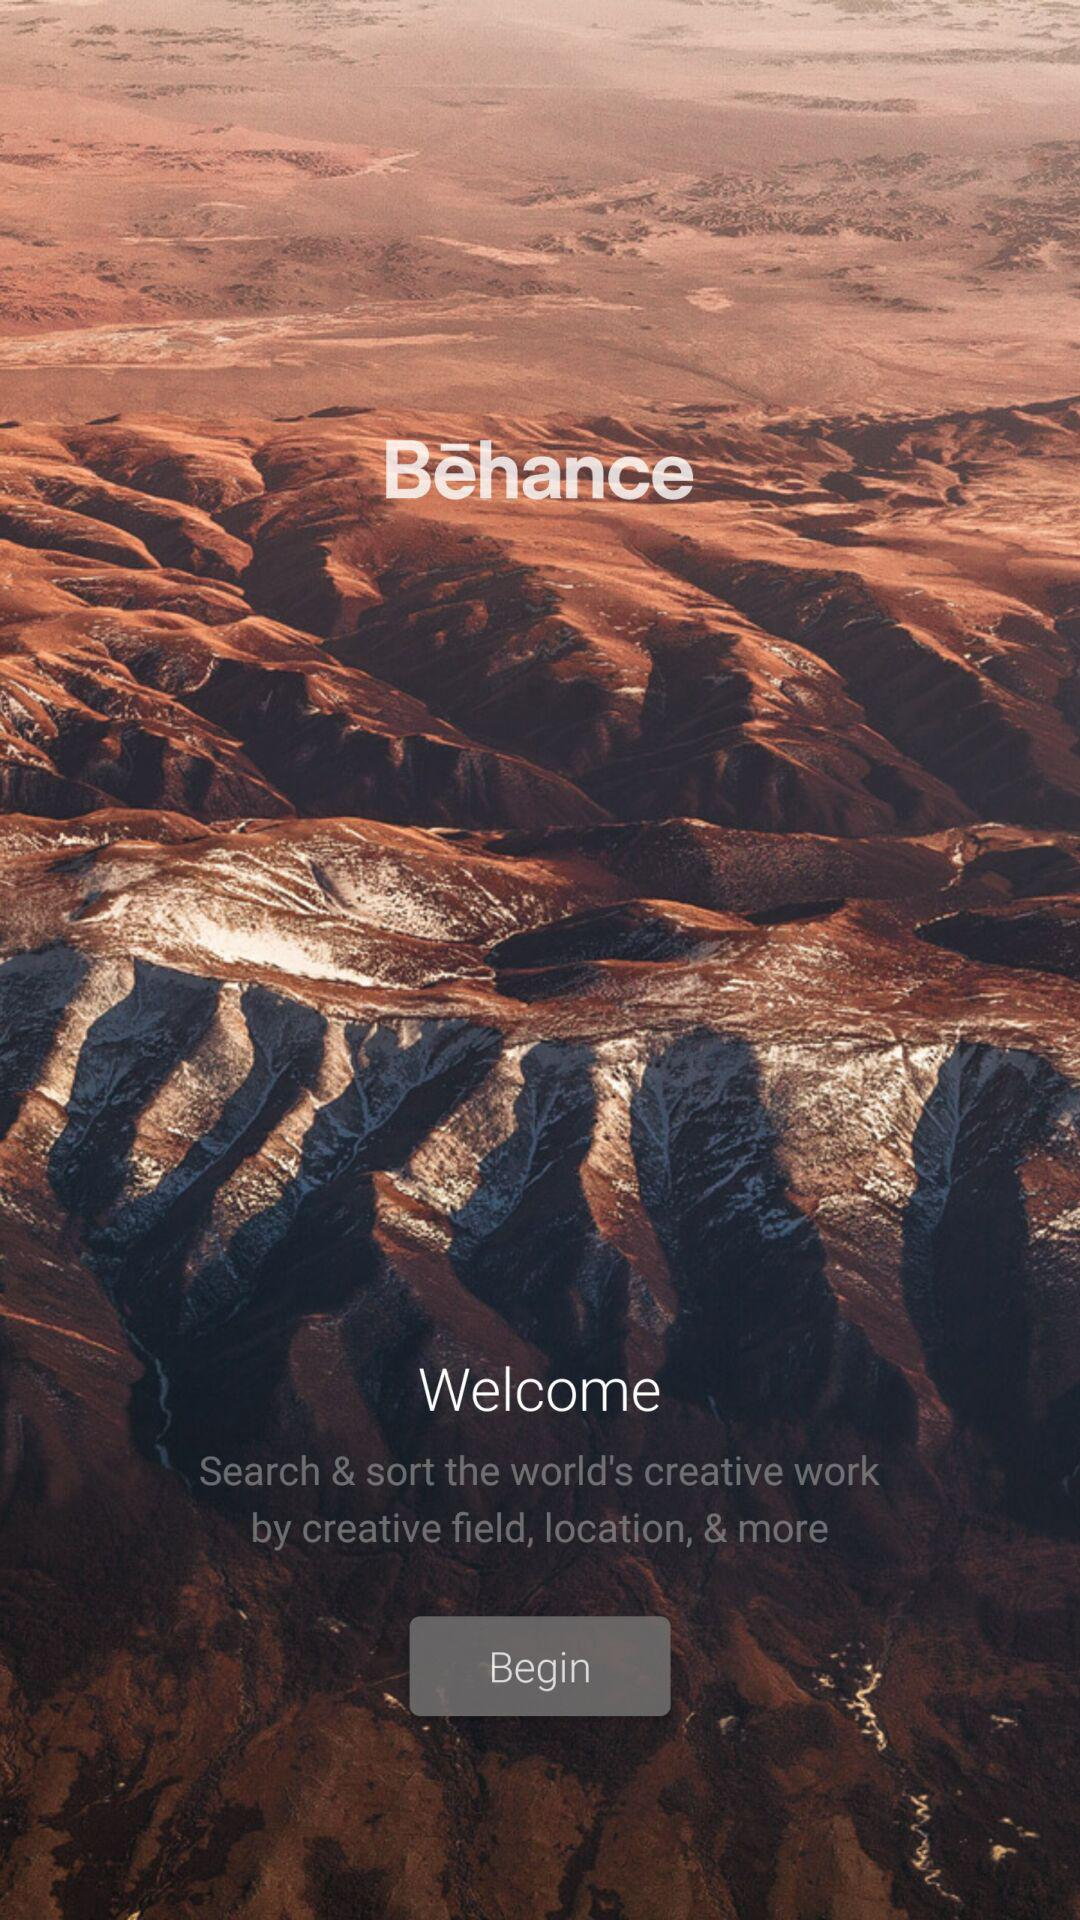What is the application name? The application name is "Bēhance". 